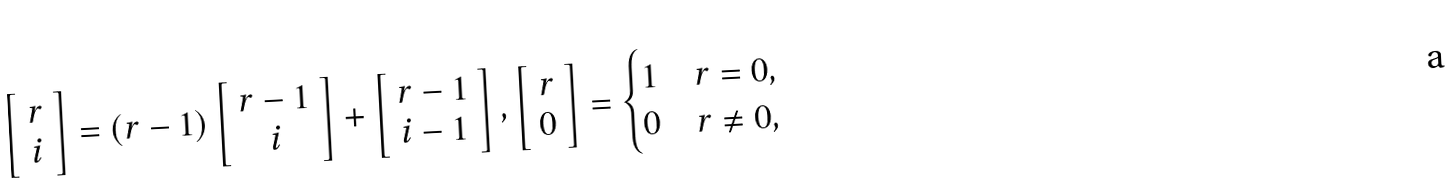Convert formula to latex. <formula><loc_0><loc_0><loc_500><loc_500>\left [ \begin{array} { c } r \\ i \end{array} \right ] = ( r - 1 ) \left [ \begin{array} { c } r - 1 \\ i \end{array} \right ] + \left [ \begin{array} { c } r - 1 \\ i - 1 \end{array} \right ] , \left [ \begin{array} { c } r \\ 0 \end{array} \right ] = \begin{cases} 1 & r = 0 , \\ 0 & r \neq 0 , \end{cases}</formula> 